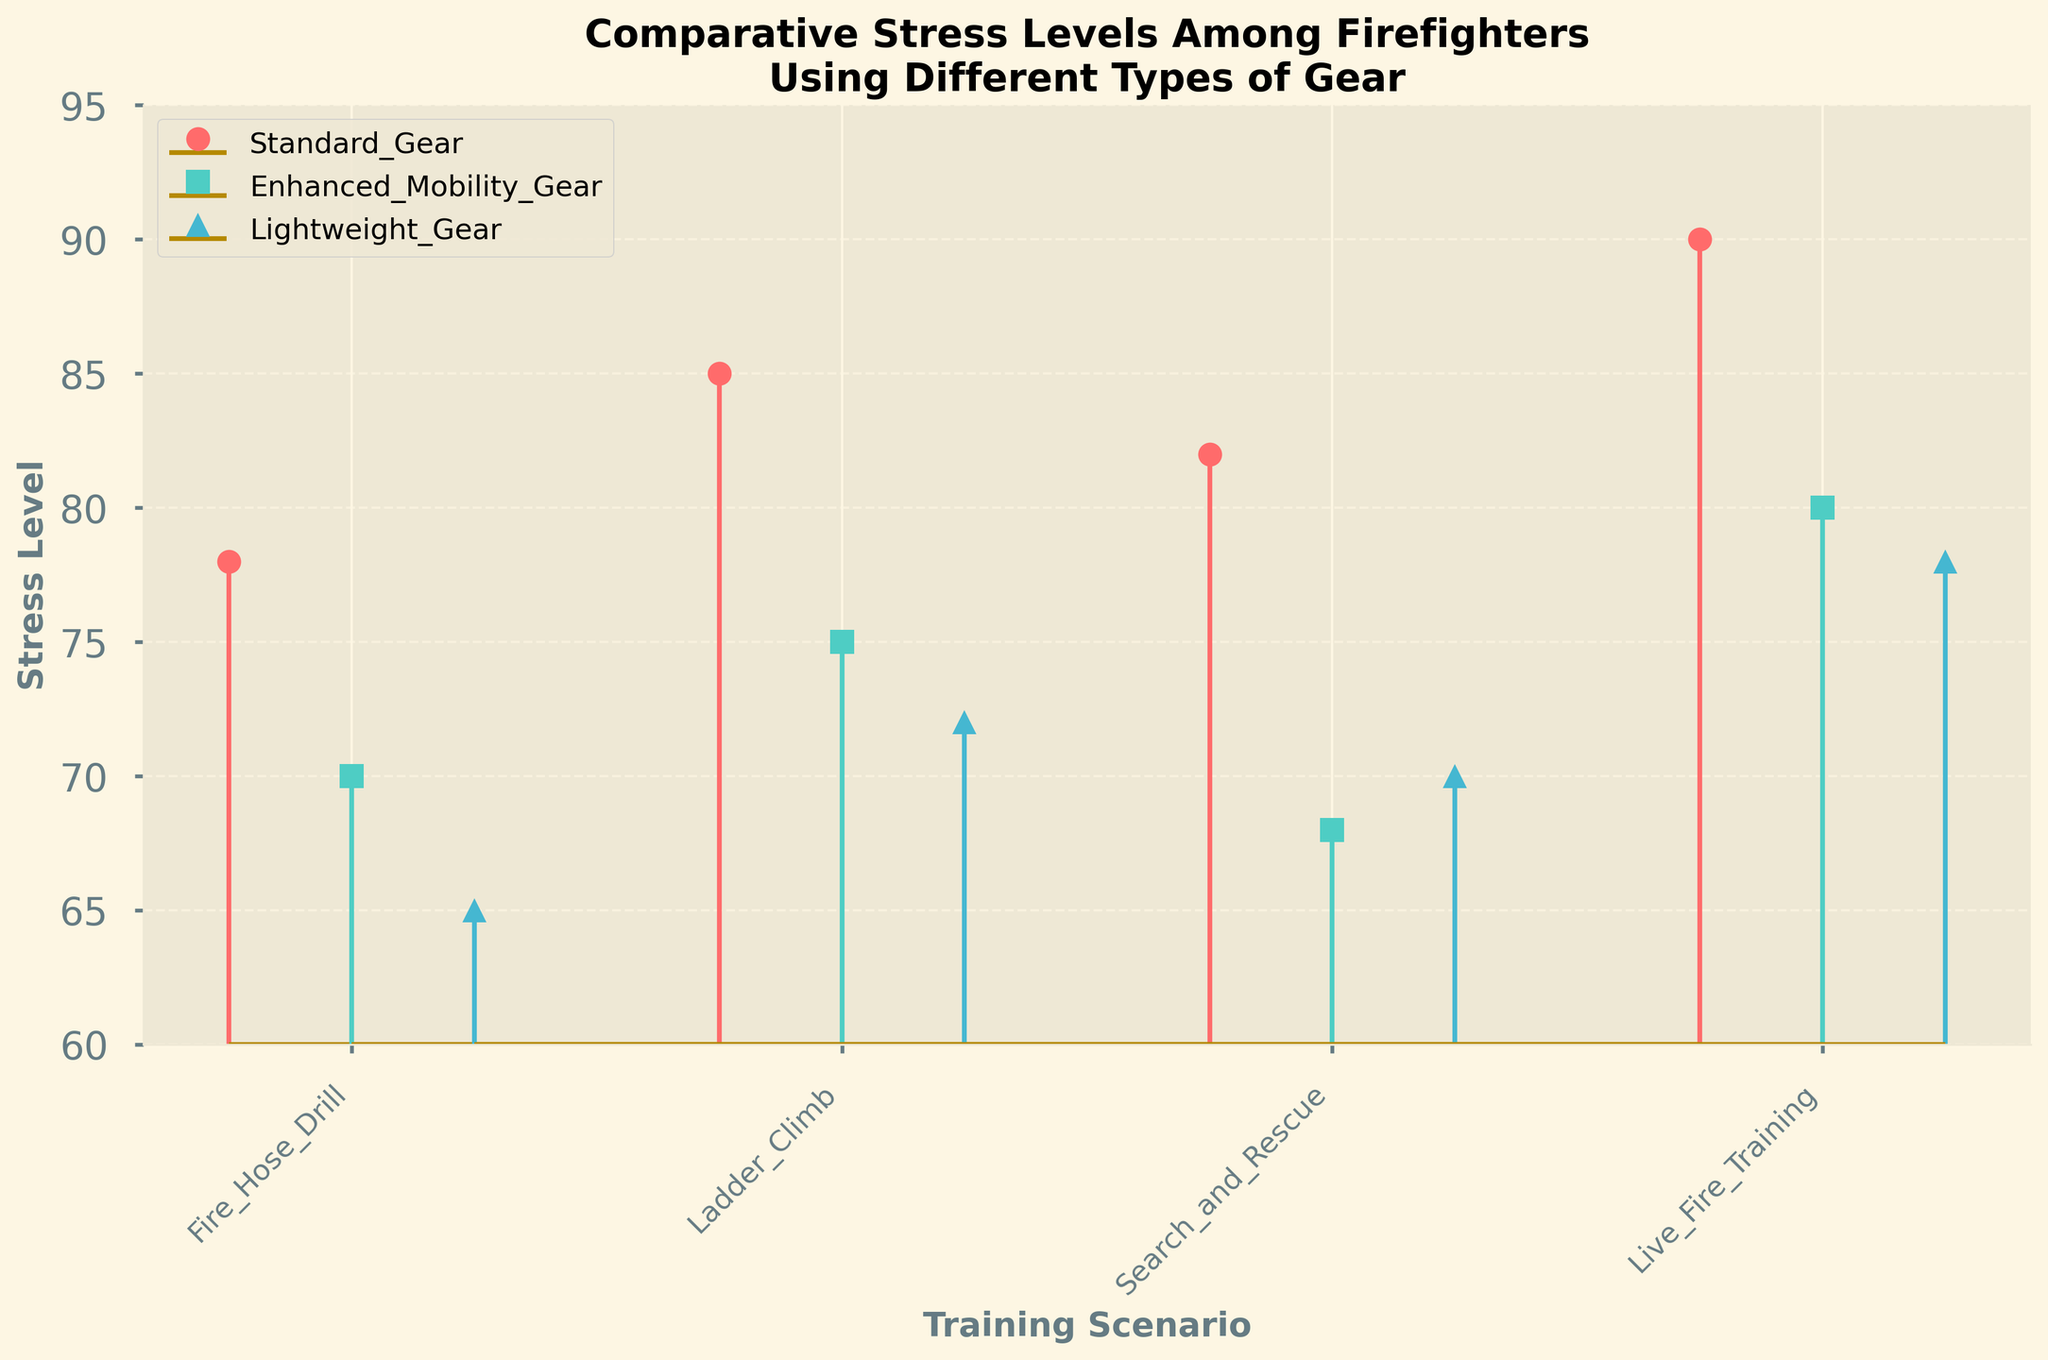What is the title of the figure? The title of the figure is usually located at the top and provides a summary of what the figure is about. From the given data and code, the title should indicate a comparison of stress levels among firefighters using different types of gear during training scenarios.
Answer: Comparative Stress Levels Among Firefighters Using Different Types of Gear What are the three types of gear shown in the figure? The types of gear are usually listed in a legend or directly on the plot. In this case, the types of gear are mentioned in the provided data and code as well.
Answer: Standard Gear, Enhanced Mobility Gear, Lightweight Gear Which training scenario shows the highest stress level for Standard Gear? By looking at the plotted stress levels for Standard Gear in each training scenario, the highest value can be identified.
Answer: Live Fire Training How does the stress level in the Fire Hose Drill scenario compare across the three types of gear? Compare the stress level marks for Fire Hose Drill across the different gear types. Standard Gear (78), Enhanced Mobility Gear (70), Lightweight Gear (65)
Answer: Lightweight Gear has the lowest stress level, followed by Enhanced Mobility Gear, with Standard Gear having the highest What's the average stress level for Enhanced Mobility Gear across all training scenarios? Calculate the average by adding the stress level values for Enhanced Mobility Gear and dividing by the number of scenarios. (70 + 75 + 68 + 80) / 4 = 73.25
Answer: 73.25 What is the difference in stress levels between the Ladder Climb scenario for Standard Gear and Lightweight Gear? Determine the stress levels for Ladder Climb for both Standard Gear and Lightweight Gear from the figure, then subtract one from the other. 85 (Standard) - 72 (Lightweight)
Answer: 13 Which type of gear shows the lowest stress level during Search and Rescue? Compare the plotted stress levels for Search and Rescue among the different gear types. Standard: 82, Enhanced Mobility: 68, Lightweight: 70
Answer: Enhanced Mobility Gear Which training scenario causes the least stress for Lightweight Gear? Look at the stress levels associated with Lightweight Gear across all scenarios and identify the lowest.
Answer: Fire Hose Drill What's the overall trend in stress levels for Standard Gear across different training scenarios? Observe the pattern of stress levels for Standard Gear across all scenarios to describe the trend: Fire Hose Drill (78), Ladder Climb (85), Search and Rescue (82), Live Fire Training (90).
Answer: Increasing stress levels with each training scenario 